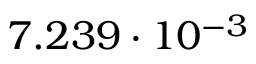<formula> <loc_0><loc_0><loc_500><loc_500>7 . 2 3 9 \cdot 1 0 ^ { - 3 }</formula> 